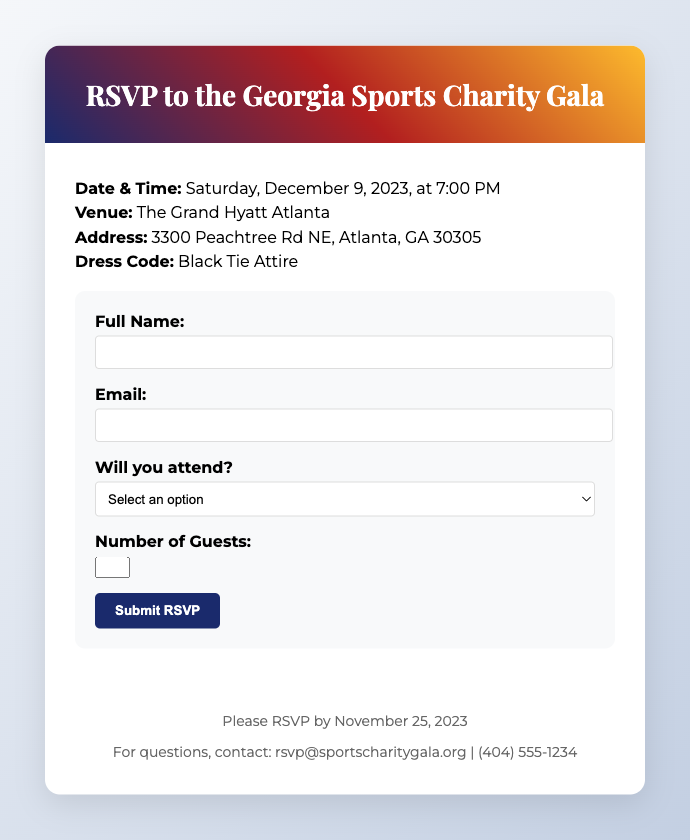What is the date of the gala? The date of the gala is highlighted in the document as Saturday, December 9, 2023.
Answer: Saturday, December 9, 2023 What is the venue for the event? The venue is stated in the document where the gala will take place, which is The Grand Hyatt Atlanta.
Answer: The Grand Hyatt Atlanta What is the dress code for attendees? The dress code is specified in the document, which requires Black Tie Attire for the event.
Answer: Black Tie Attire When is the RSVP deadline? The deadline for RSVPs is mentioned in the footer of the document as November 25, 2023.
Answer: November 25, 2023 How many guests can you include in your RSVP? The document states a maximum number of guests that can be included, which is 2.
Answer: 2 What email should questions be directed to? The document provides contact information, where questions can be sent to rsvp@sportscharitygala.org.
Answer: rsvp@sportscharitygala.org What time does the gala start? The time is clearly indicated in the document, specifying 7:00 PM as the start time.
Answer: 7:00 PM What is required in the RSVP form? The RSVP form includes fields for full name, email, attendance, and number of guests.
Answer: Full name, email, attendance, number of guests Why is this gala being held? The purpose of the gala is to support youth sports programs in Georgia, as indicated in the invitation.
Answer: Support youth sports programs in Georgia 